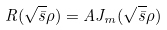Convert formula to latex. <formula><loc_0><loc_0><loc_500><loc_500>R ( \sqrt { \bar { s } } \rho ) = A J _ { m } ( \sqrt { \bar { s } } \rho )</formula> 